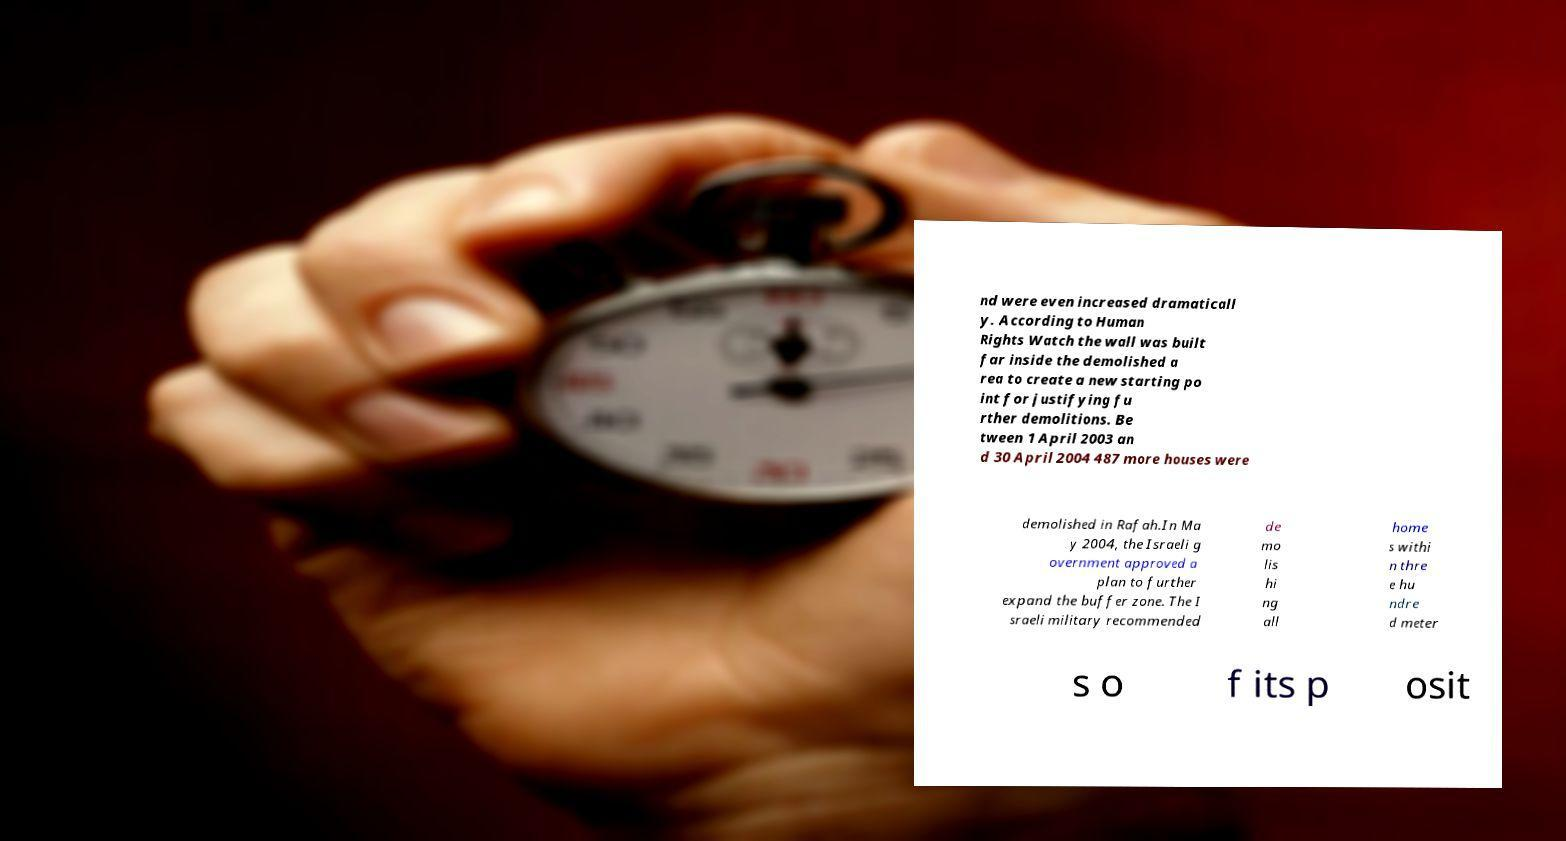Please identify and transcribe the text found in this image. nd were even increased dramaticall y. According to Human Rights Watch the wall was built far inside the demolished a rea to create a new starting po int for justifying fu rther demolitions. Be tween 1 April 2003 an d 30 April 2004 487 more houses were demolished in Rafah.In Ma y 2004, the Israeli g overnment approved a plan to further expand the buffer zone. The I sraeli military recommended de mo lis hi ng all home s withi n thre e hu ndre d meter s o f its p osit 